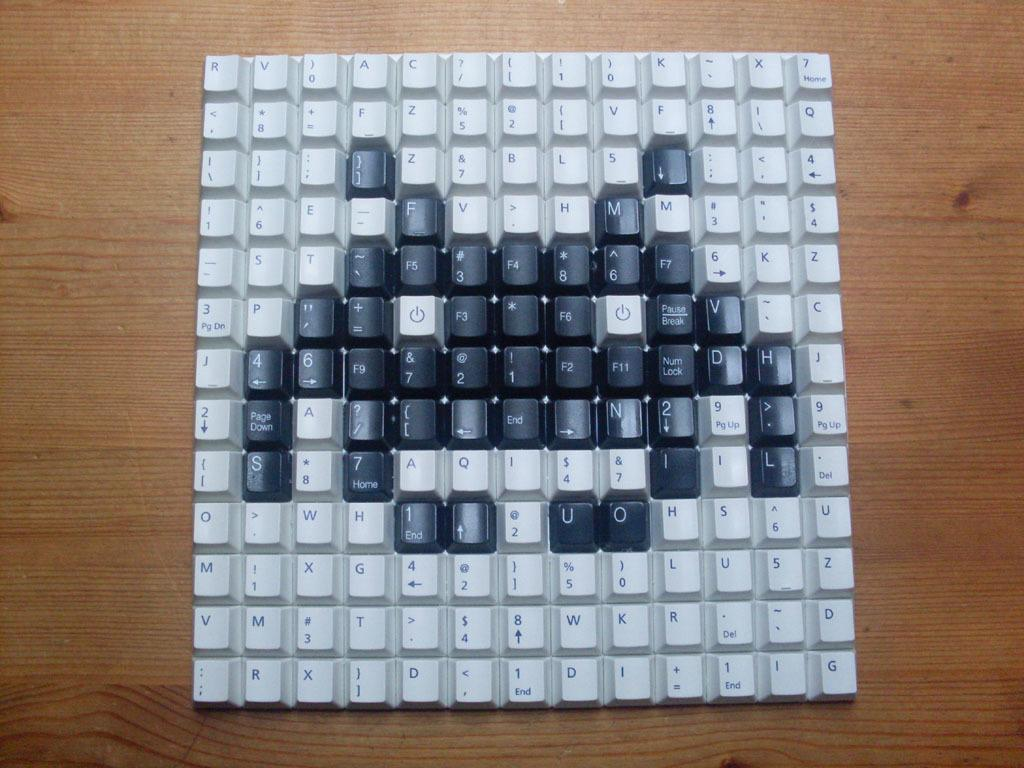<image>
Describe the image concisely. A keyboard sitting on a desk with the letters u and o showing. 